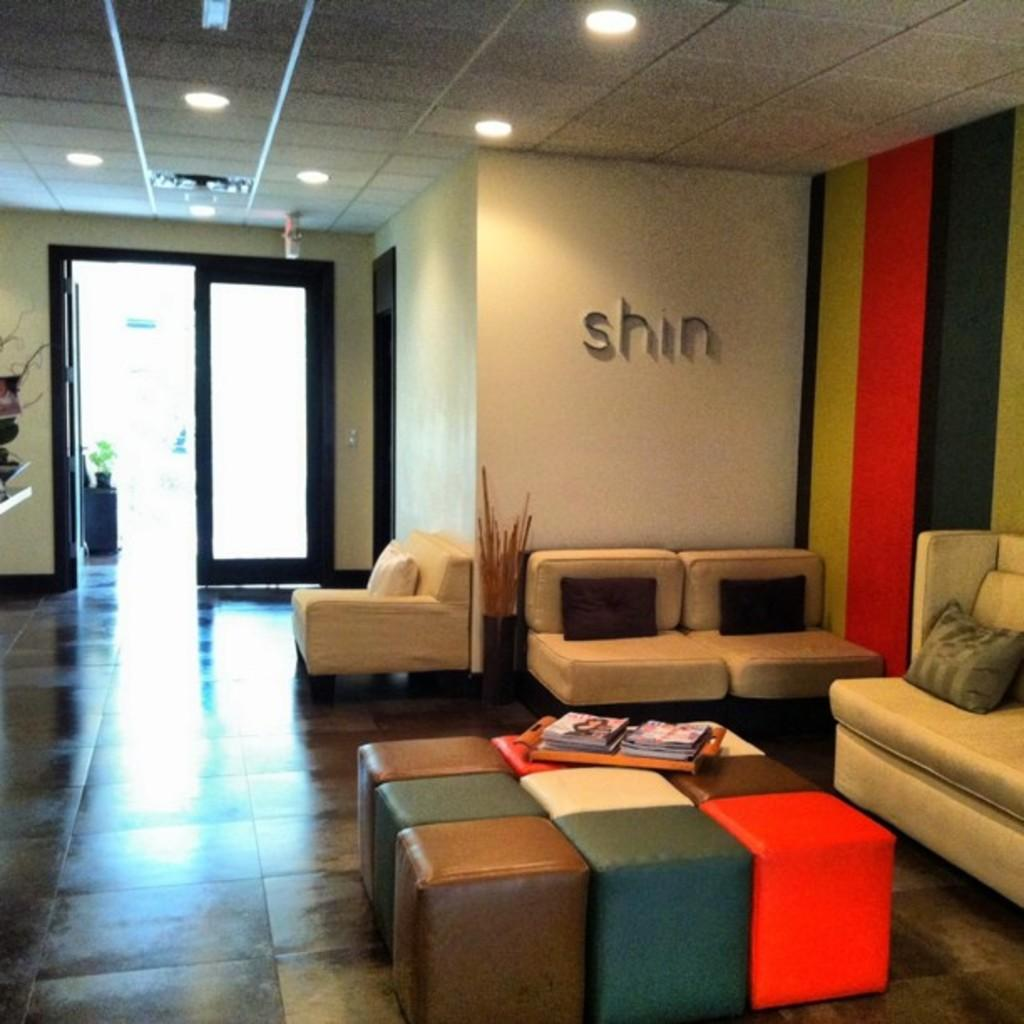What type of space is depicted in the image? There is a room in the image. What type of furniture is present in the room? There are sofas, pillows, stools, and a tray with books in the room. What is the location of the room? The room is outdoors. What type of structure is present in the room? There is a wall in the room. What type of surface is underfoot in the room? There is a floor in the room. What type of lighting is present in the room? There are lights in the room. How many mice can be seen playing with the books on the tray in the image? There are no mice present in the image. What type of dog is sitting on the sofa in the image? There are no dogs present in the image. 